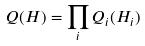Convert formula to latex. <formula><loc_0><loc_0><loc_500><loc_500>Q ( H ) = \prod _ { i } Q _ { i } ( H _ { i } )</formula> 